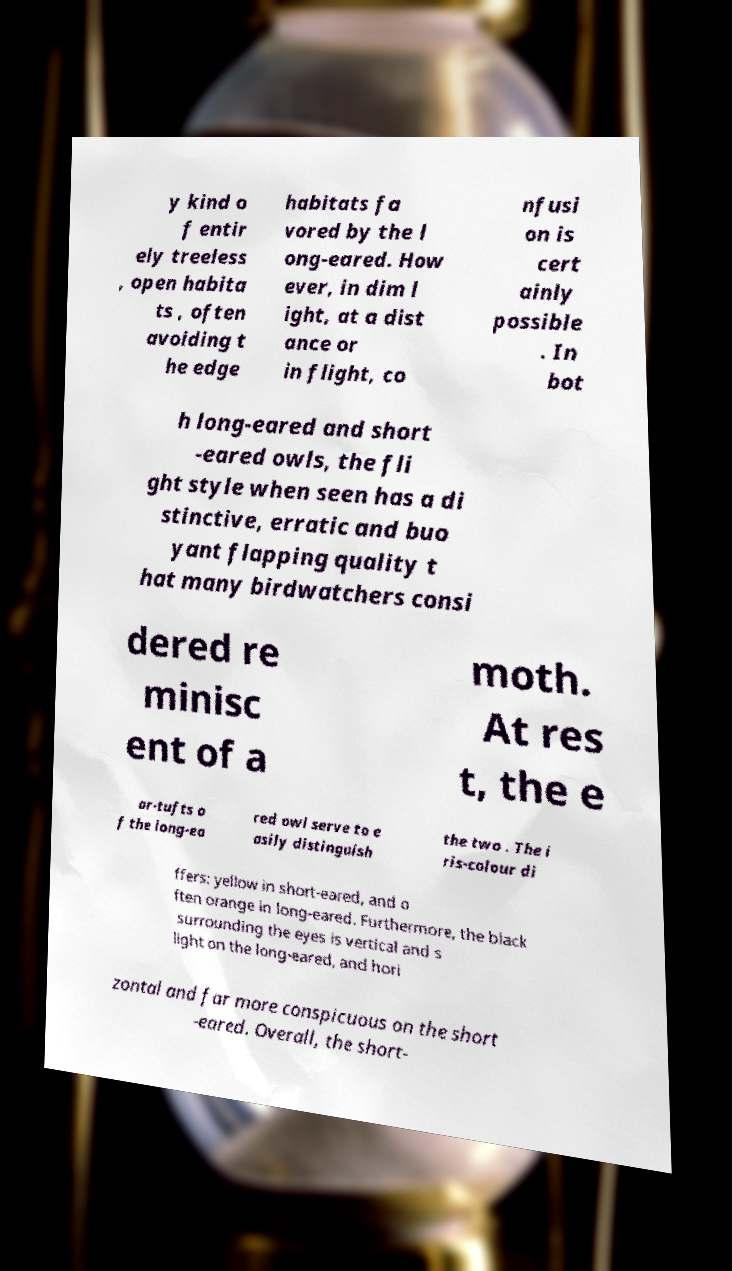There's text embedded in this image that I need extracted. Can you transcribe it verbatim? y kind o f entir ely treeless , open habita ts , often avoiding t he edge habitats fa vored by the l ong-eared. How ever, in dim l ight, at a dist ance or in flight, co nfusi on is cert ainly possible . In bot h long-eared and short -eared owls, the fli ght style when seen has a di stinctive, erratic and buo yant flapping quality t hat many birdwatchers consi dered re minisc ent of a moth. At res t, the e ar-tufts o f the long-ea red owl serve to e asily distinguish the two . The i ris-colour di ffers: yellow in short-eared, and o ften orange in long-eared. Furthermore, the black surrounding the eyes is vertical and s light on the long-eared, and hori zontal and far more conspicuous on the short -eared. Overall, the short- 